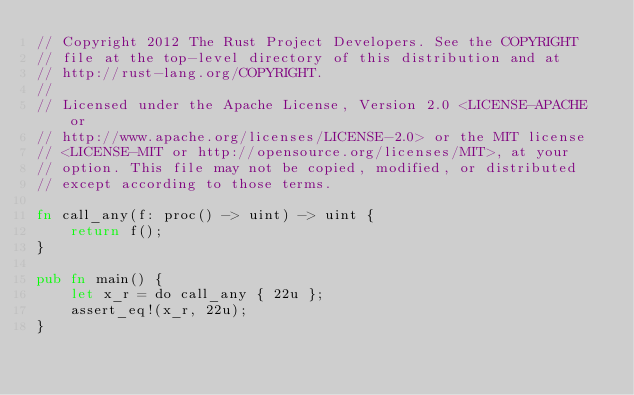<code> <loc_0><loc_0><loc_500><loc_500><_Rust_>// Copyright 2012 The Rust Project Developers. See the COPYRIGHT
// file at the top-level directory of this distribution and at
// http://rust-lang.org/COPYRIGHT.
//
// Licensed under the Apache License, Version 2.0 <LICENSE-APACHE or
// http://www.apache.org/licenses/LICENSE-2.0> or the MIT license
// <LICENSE-MIT or http://opensource.org/licenses/MIT>, at your
// option. This file may not be copied, modified, or distributed
// except according to those terms.

fn call_any(f: proc() -> uint) -> uint {
    return f();
}

pub fn main() {
    let x_r = do call_any { 22u };
    assert_eq!(x_r, 22u);
}
</code> 